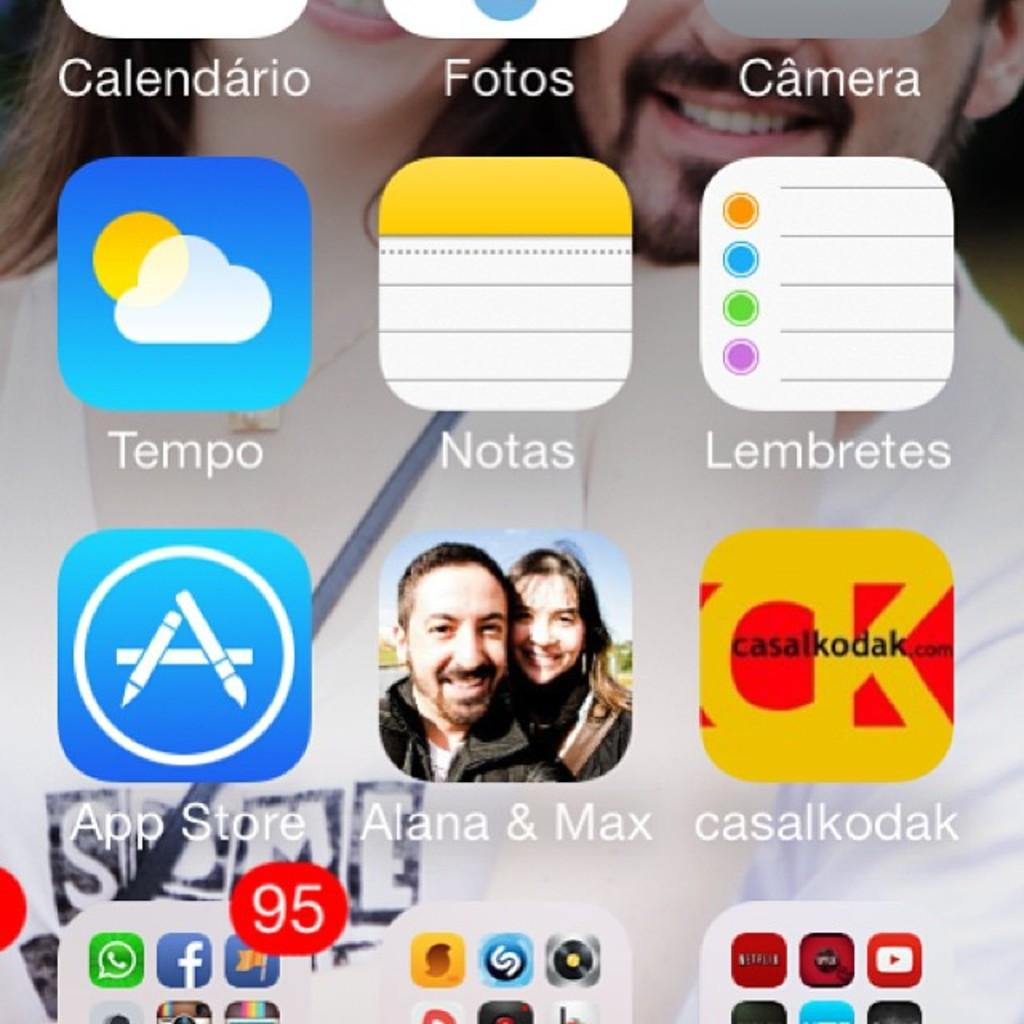What is displayed on the screen in the image? There are icons on the screen in the image. What type of jelly can be seen on the floor in the image? There is no jelly or floor present in the image; it only shows icons on a screen. 